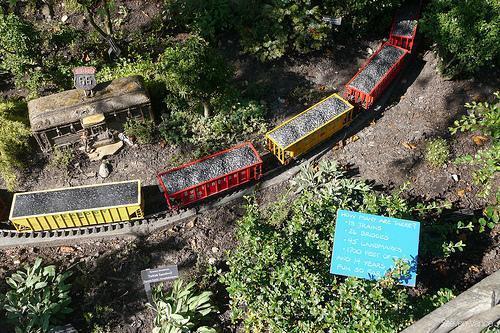How many train cars are yellow?
Give a very brief answer. 2. How many train cars are red?
Give a very brief answer. 3. How many red train cars are there?
Give a very brief answer. 3. 